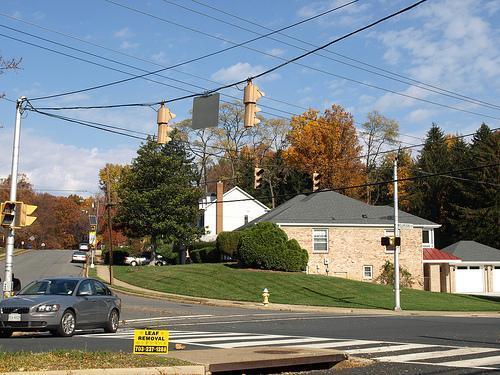How many signs are there?
Give a very brief answer. 1. 